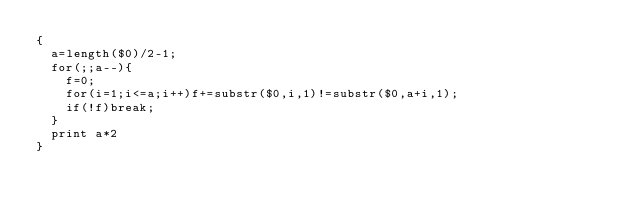<code> <loc_0><loc_0><loc_500><loc_500><_Awk_>{
	a=length($0)/2-1;
	for(;;a--){
		f=0;
		for(i=1;i<=a;i++)f+=substr($0,i,1)!=substr($0,a+i,1);
		if(!f)break;
	}
	print a*2
}</code> 